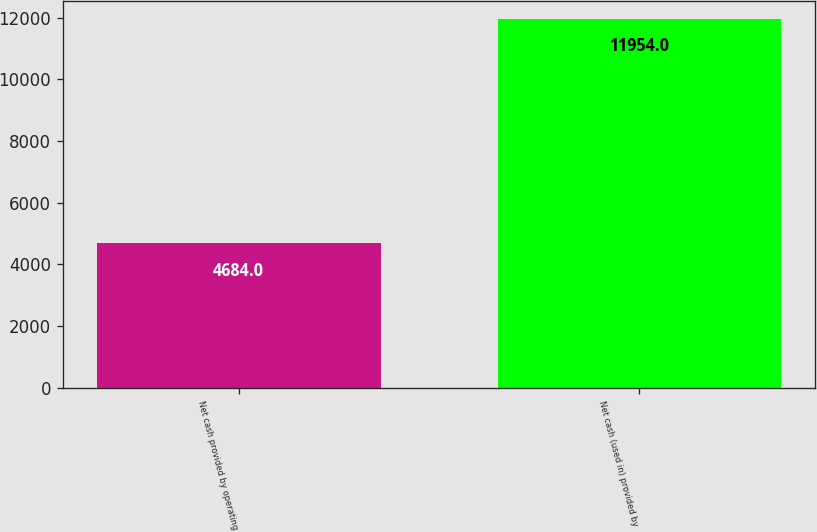<chart> <loc_0><loc_0><loc_500><loc_500><bar_chart><fcel>Net cash provided by operating<fcel>Net cash (used in) provided by<nl><fcel>4684<fcel>11954<nl></chart> 